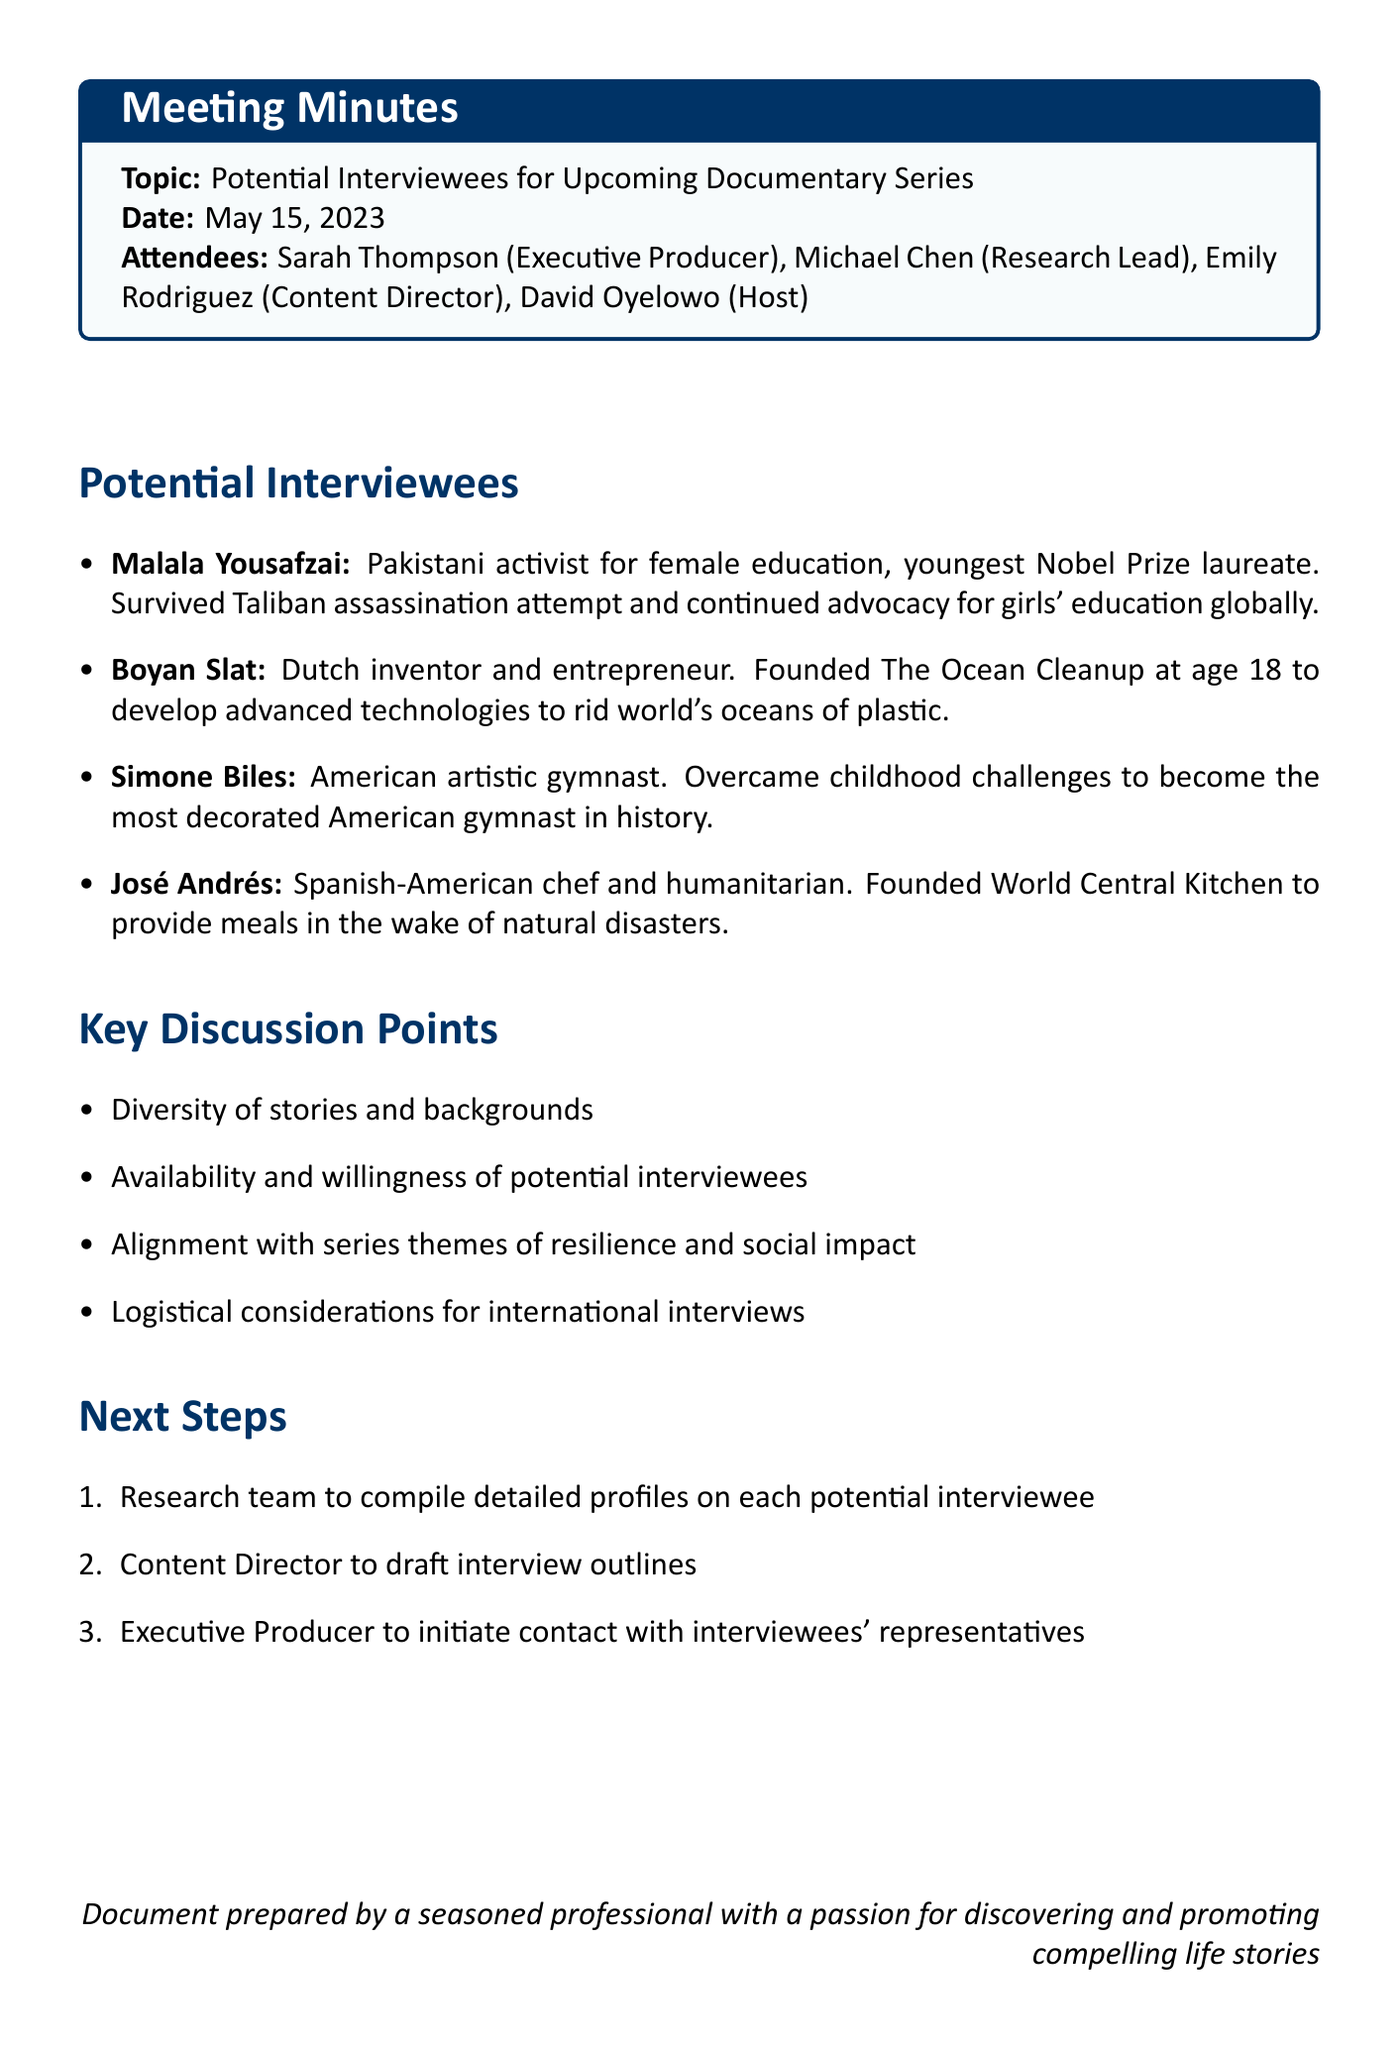What is the date of the meeting? The date of the meeting is explicitly stated in the document.
Answer: May 15, 2023 Who is the Executive Producer? The document lists the attendees and their roles clearly.
Answer: Sarah Thompson What unique story is associated with Malala Yousafzai? The document provides a unique story tied to each potential interviewee.
Answer: Survived Taliban assassination attempt and continued advocacy for girls' education globally How many potential interviewees are listed? The total number of potential interviewees is detailed in the document.
Answer: Four What theme aligns with the series according to the discussion points? The key discussion points mention themes that guide the selection of interviewees.
Answer: Resilience and social impact What is the next step assigned to the Research team? The document specifies action items for the next steps.
Answer: Compile detailed profiles on each potential interviewee Who is the Host for the documentary series? The roles of the attendees include the host's name.
Answer: David Oyelowo What is a logistical consideration mentioned for the interviews? Key discussion points include logistical considerations that are crucial for planning.
Answer: International interviews 